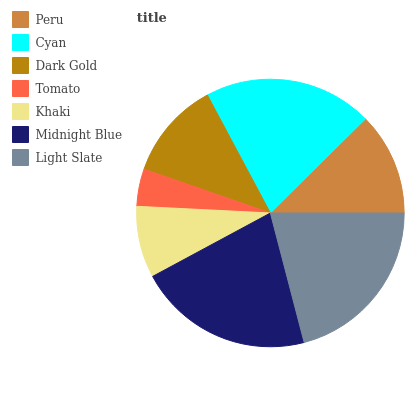Is Tomato the minimum?
Answer yes or no. Yes. Is Midnight Blue the maximum?
Answer yes or no. Yes. Is Cyan the minimum?
Answer yes or no. No. Is Cyan the maximum?
Answer yes or no. No. Is Cyan greater than Peru?
Answer yes or no. Yes. Is Peru less than Cyan?
Answer yes or no. Yes. Is Peru greater than Cyan?
Answer yes or no. No. Is Cyan less than Peru?
Answer yes or no. No. Is Peru the high median?
Answer yes or no. Yes. Is Peru the low median?
Answer yes or no. Yes. Is Dark Gold the high median?
Answer yes or no. No. Is Khaki the low median?
Answer yes or no. No. 